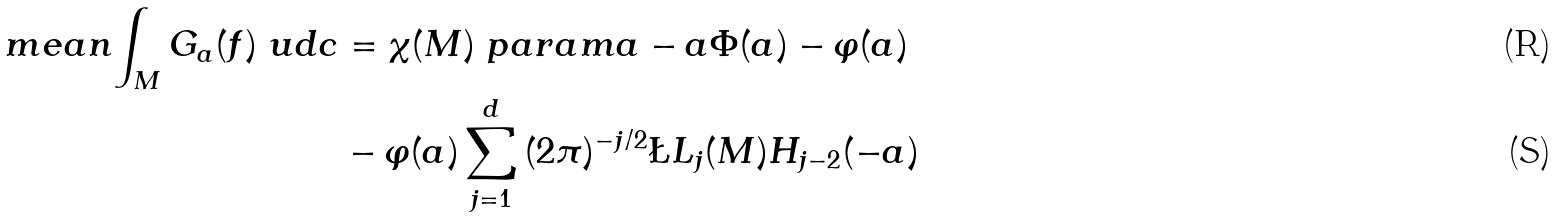<formula> <loc_0><loc_0><loc_500><loc_500>\ m e a n { \int _ { M } { G _ { a } ( f ) \ u d c } } & = \chi ( M ) \ p a r a m { a - a \Phi ( a ) - \varphi ( a ) } \\ & - \varphi ( a ) \sum _ { j = 1 } ^ { d } { ( 2 \pi ) ^ { - j / 2 } \L L _ { j } ( M ) H _ { j - 2 } ( - a ) }</formula> 